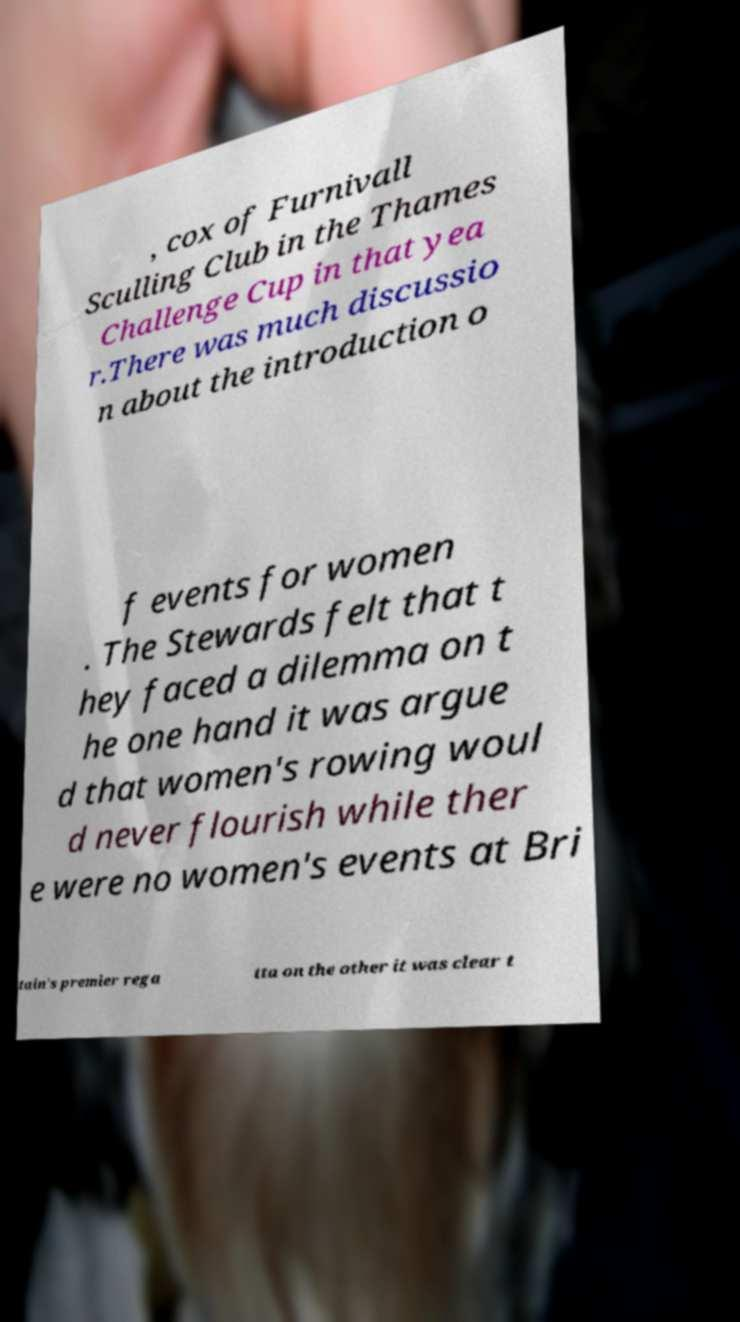There's text embedded in this image that I need extracted. Can you transcribe it verbatim? , cox of Furnivall Sculling Club in the Thames Challenge Cup in that yea r.There was much discussio n about the introduction o f events for women . The Stewards felt that t hey faced a dilemma on t he one hand it was argue d that women's rowing woul d never flourish while ther e were no women's events at Bri tain's premier rega tta on the other it was clear t 